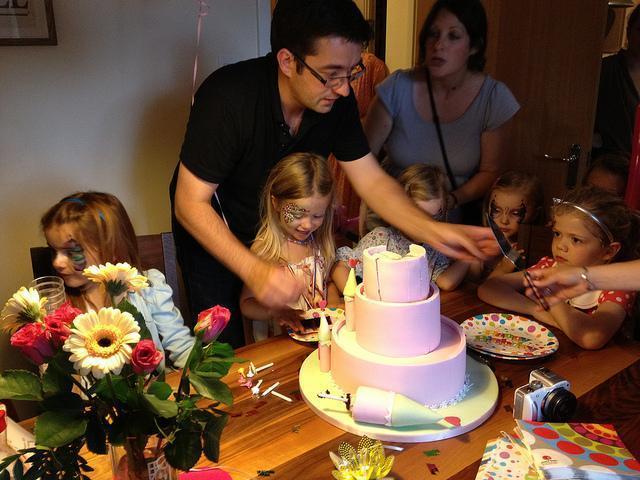How many kids in the picture?
Give a very brief answer. 6. How many people are there?
Give a very brief answer. 9. How many skis is the boy holding?
Give a very brief answer. 0. 